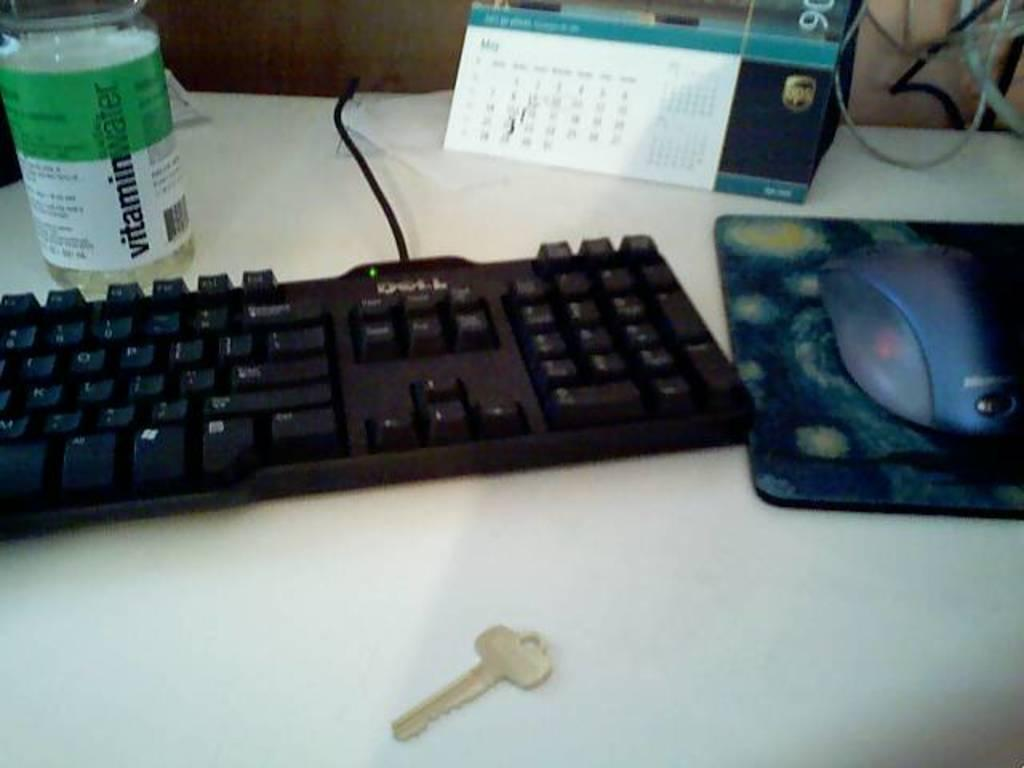What object can be seen in the image that is typically used for holding liquids? There is a bottle in the image. What object can be seen in the image that is typically used for typing? There is a keyboard in the image. What object can be seen in the image that is typically used for displaying dates and events? There is a calendar in the image. What object can be seen in the image that is typically used for controlling a cursor on a screen? There is a mouse in the image. What object can be seen in the image that is typically used as a surface for a mouse to move on? There is a mouse pad in the image. What object can be seen in the image that is typically used for unlocking or locking a door or a padlock? There is a key in the image. What is the color of the surface on which the objects are placed in the image? The objects are on a white surface. What can be seen in the top right corner of the image? Wires are present in the top right corner of the image. How does the tent in the image provide shelter from the rain? There is no tent present in the image. What is the effect of the stop sign on the traffic in the image? There is no stop sign present in the image. 